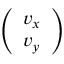Convert formula to latex. <formula><loc_0><loc_0><loc_500><loc_500>\left ( \begin{array} { l } { v _ { x } } \\ { v _ { y } } \end{array} \right )</formula> 